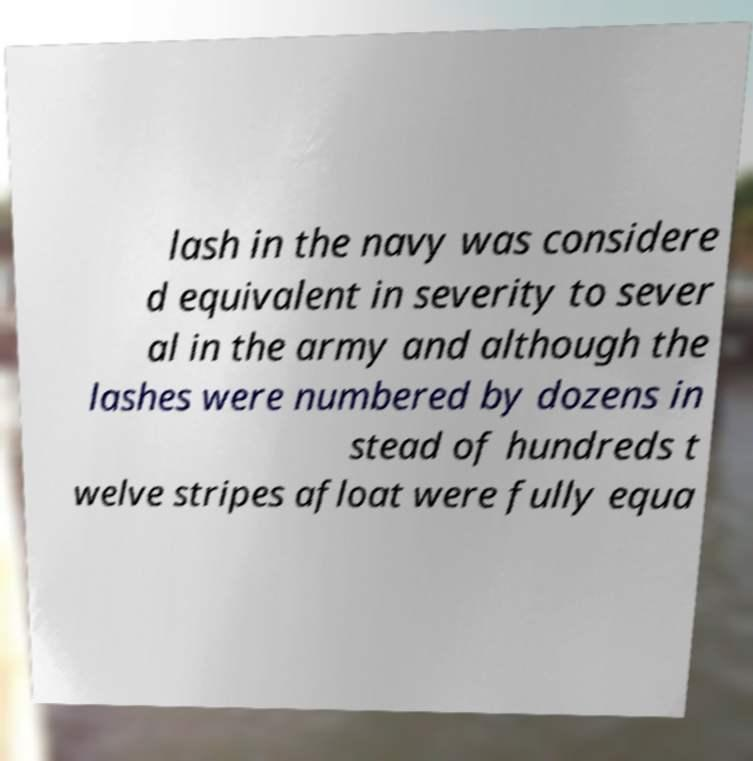I need the written content from this picture converted into text. Can you do that? lash in the navy was considere d equivalent in severity to sever al in the army and although the lashes were numbered by dozens in stead of hundreds t welve stripes afloat were fully equa 